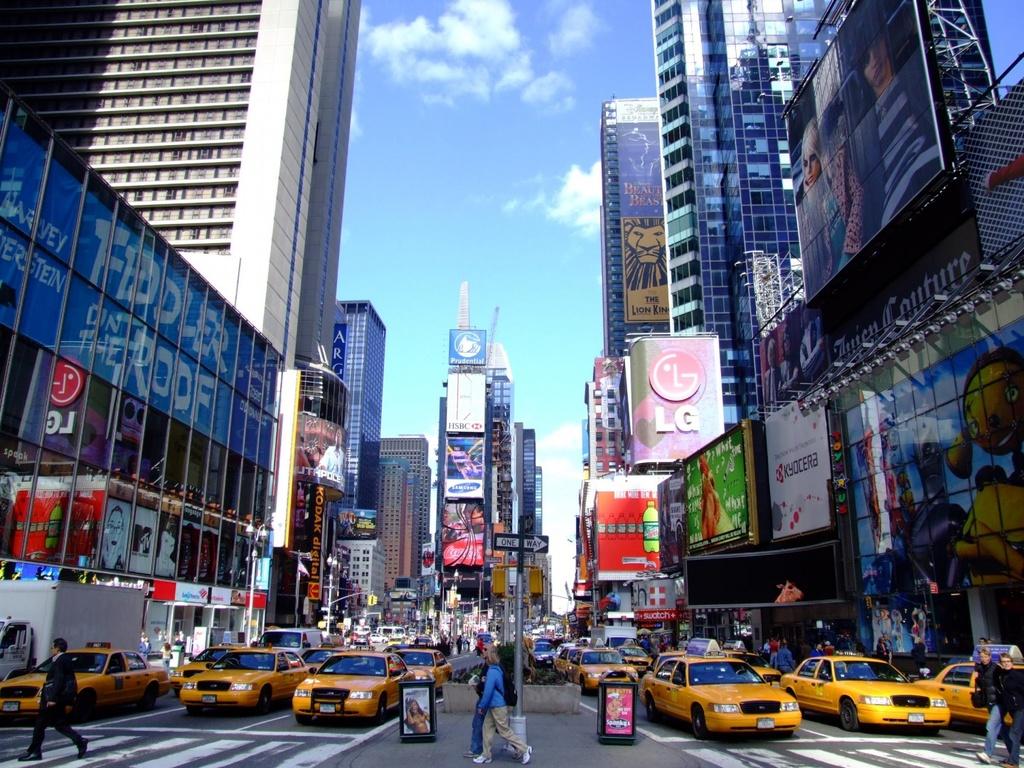What brand is being advertised here?
Your answer should be very brief. Lg. 